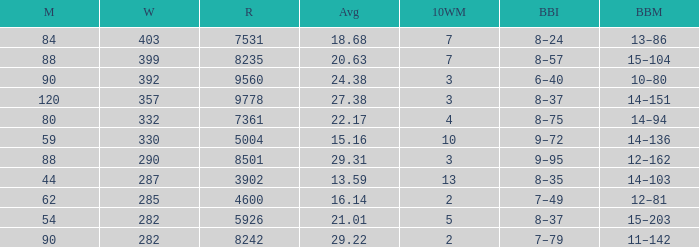What is the sum of runs that are associated with 10WM values over 13? None. 